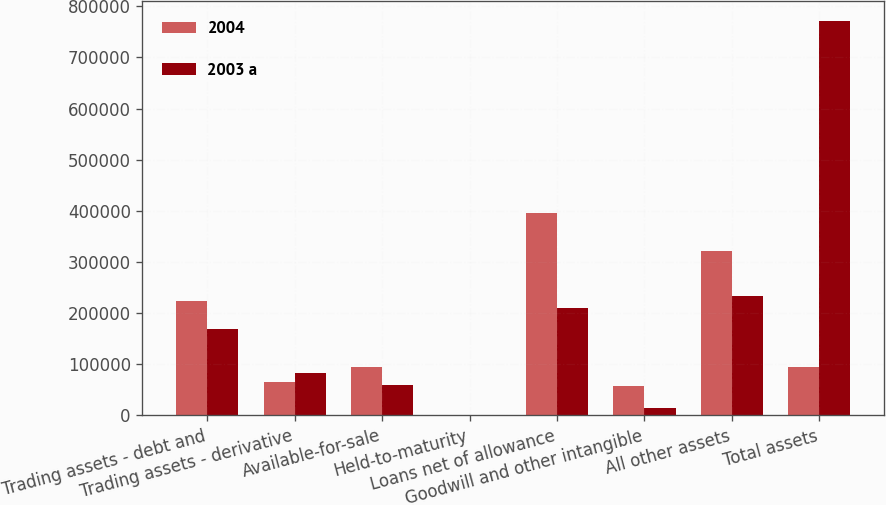<chart> <loc_0><loc_0><loc_500><loc_500><stacked_bar_chart><ecel><fcel>Trading assets - debt and<fcel>Trading assets - derivative<fcel>Available-for-sale<fcel>Held-to-maturity<fcel>Loans net of allowance<fcel>Goodwill and other intangible<fcel>All other assets<fcel>Total assets<nl><fcel>2004<fcel>222832<fcel>65982<fcel>94402<fcel>110<fcel>394794<fcel>57887<fcel>321241<fcel>94402<nl><fcel>2003 a<fcel>169120<fcel>83751<fcel>60068<fcel>176<fcel>210243<fcel>14991<fcel>232563<fcel>770912<nl></chart> 